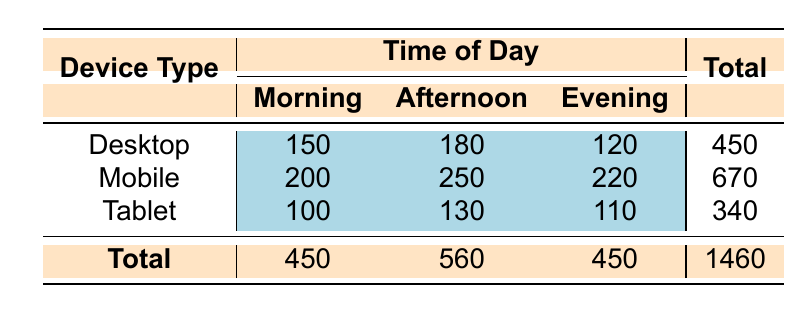What is the total user engagement level for Desktop devices? To find the total user engagement level for Desktop devices, we look at the corresponding row in the table. The values for Desktop are Morning: 150, Afternoon: 180, and Evening: 120. Adding these together: 150 + 180 + 120 = 450.
Answer: 450 Which device type has the highest user engagement level in the Afternoon? We need to check the values for the Afternoon column in the table. The values are Desktop: 180, Mobile: 250, and Tablet: 130. The highest value is for Mobile at 250.
Answer: Mobile What is the average user engagement level for Mobile devices across all times of day? The user engagement levels for Mobile are 200 (Morning), 250 (Afternoon), and 220 (Evening). We sum these values: 200 + 250 + 220 = 670. Then, dividing by the number of data points (3): 670 / 3 = approximately 223.33.
Answer: Approximately 223.33 Is the user engagement level in the Evening higher for Desktop devices than for Tablet devices? We can compare the Evening values for both device types. For Desktop, the Evening engagement level is 120, and for Tablet, it’s 110. Since 120 is greater than 110, the answer is yes.
Answer: Yes What is the total user engagement level during Morning for all device types combined? We need to look at the Morning column for all devices: Desktop: 150, Mobile: 200, and Tablet: 100. Adding these together gives us: 150 + 200 + 100 = 450.
Answer: 450 Which time of day has the lowest total user engagement level? To find this, we look at the totals for each time of day. Morning: 450, Afternoon: 560, Evening: 450. The lowest values are in both Morning and Evening with 450, but Afternoon has a higher engagement level of 560. Thus, Morning and Evening tie for the lowest.
Answer: Morning and Evening What is the difference in user engagement levels between Mobile and Tablet devices in the Afternoon? We look at the Afternoon values for both device types. Mobile is 250, and Tablet is 130. The difference is: 250 - 130 = 120.
Answer: 120 Which device type has the lowest total user engagement level? To find this, we look at the totals for each device type. Desktop: 450, Mobile: 670, Tablet: 340. Thus, Tablet has the lowest total engagement level.
Answer: Tablet What is the total user engagement level across all device types and time of day? We need to add the total values from the bottom row of the table: Desktop (450) + Mobile (670) + Tablet (340) = 450 + 670 + 340 = 1460.
Answer: 1460 